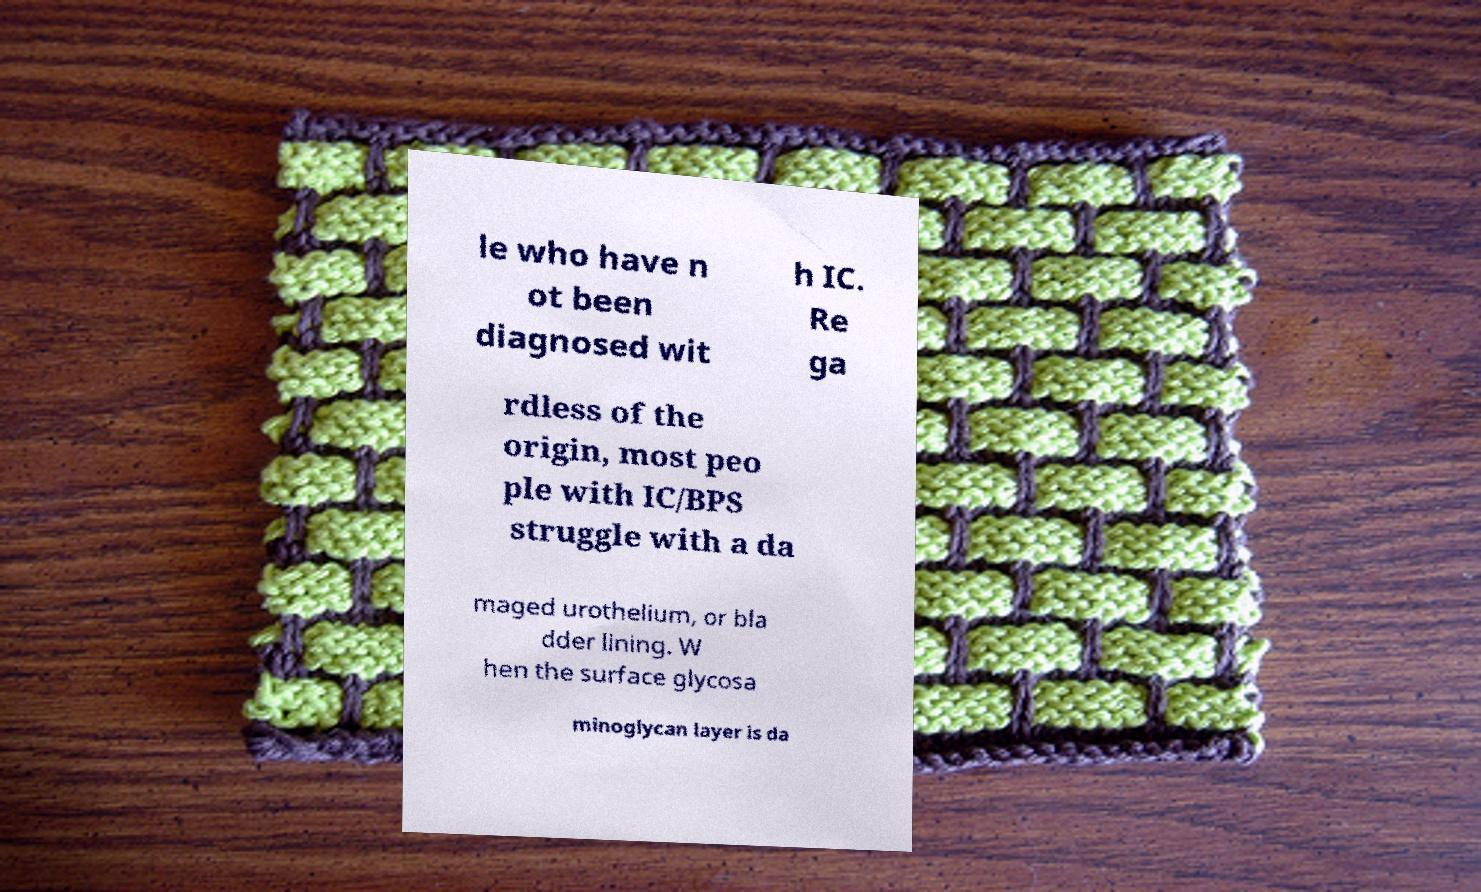I need the written content from this picture converted into text. Can you do that? le who have n ot been diagnosed wit h IC. Re ga rdless of the origin, most peo ple with IC/BPS struggle with a da maged urothelium, or bla dder lining. W hen the surface glycosa minoglycan layer is da 